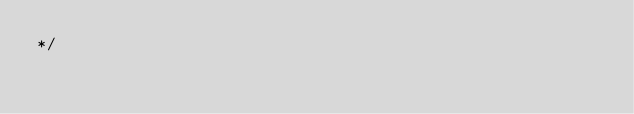<code> <loc_0><loc_0><loc_500><loc_500><_CSS_>*/</code> 